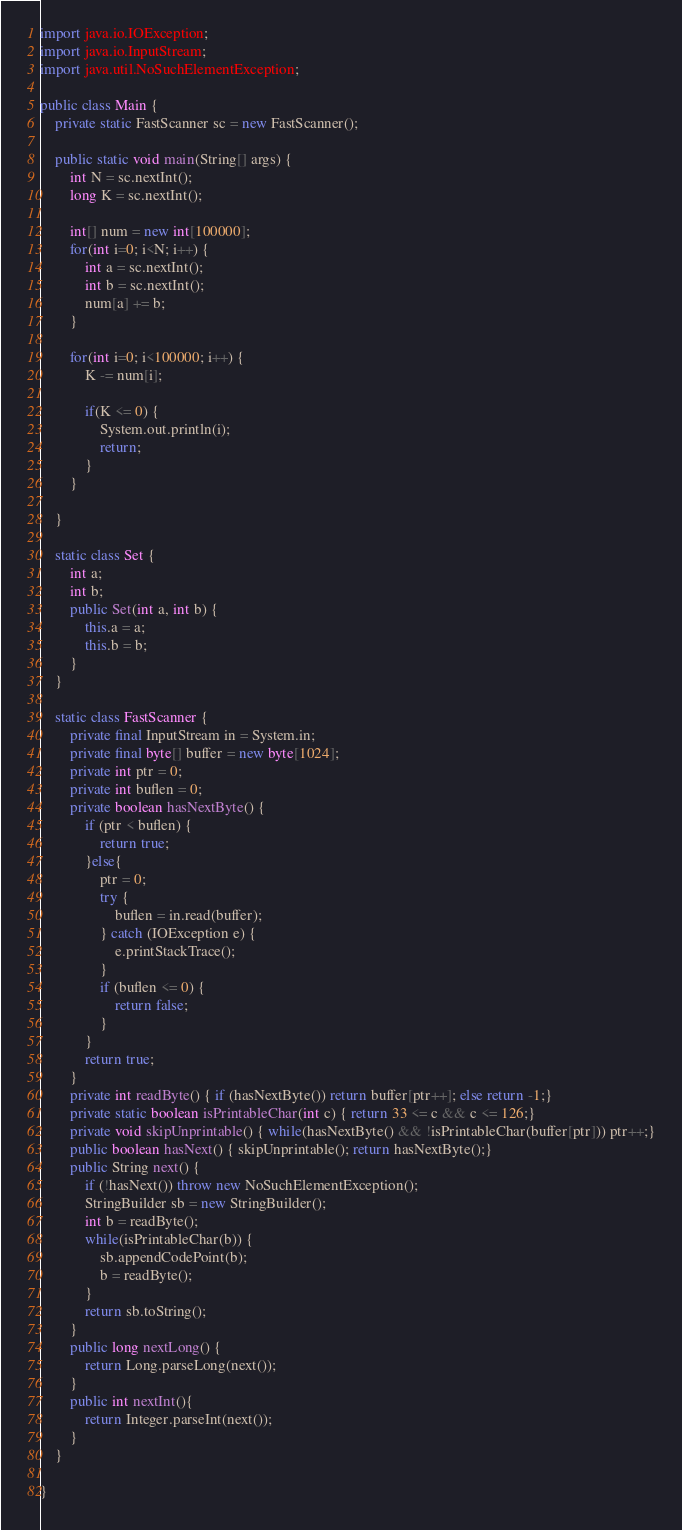Convert code to text. <code><loc_0><loc_0><loc_500><loc_500><_Java_>import java.io.IOException;
import java.io.InputStream;
import java.util.NoSuchElementException;

public class Main {
	private static FastScanner sc = new FastScanner();

	public static void main(String[] args) {
		int N = sc.nextInt();
		long K = sc.nextInt();
		
		int[] num = new int[100000];
		for(int i=0; i<N; i++) {
			int a = sc.nextInt();
			int b = sc.nextInt();
			num[a] += b;
		}
		
		for(int i=0; i<100000; i++) {
			K -= num[i];
			
			if(K <= 0) {
				System.out.println(i);
				return;
			}
		}

	}
	
	static class Set {
		int a;
		int b;
		public Set(int a, int b) {
			this.a = a;
			this.b = b;
		}
	}
	
	static class FastScanner {
	    private final InputStream in = System.in;
	    private final byte[] buffer = new byte[1024];
	    private int ptr = 0;
	    private int buflen = 0;
	    private boolean hasNextByte() {
	        if (ptr < buflen) {
	            return true;
	        }else{
	            ptr = 0;
	            try {
	                buflen = in.read(buffer);
	            } catch (IOException e) {
	                e.printStackTrace();
	            }
	            if (buflen <= 0) {
	                return false;
	            }
	        }
	        return true;
	    }
	    private int readByte() { if (hasNextByte()) return buffer[ptr++]; else return -1;}
	    private static boolean isPrintableChar(int c) { return 33 <= c && c <= 126;}
	    private void skipUnprintable() { while(hasNextByte() && !isPrintableChar(buffer[ptr])) ptr++;}
	    public boolean hasNext() { skipUnprintable(); return hasNextByte();}
	    public String next() {
	        if (!hasNext()) throw new NoSuchElementException();
	        StringBuilder sb = new StringBuilder();
	        int b = readByte();
	        while(isPrintableChar(b)) {
	            sb.appendCodePoint(b);
	            b = readByte();
	        }
	        return sb.toString();
	    }
	    public long nextLong() {
	        return Long.parseLong(next());
	    }
	    public int nextInt(){
	    	return Integer.parseInt(next());
	    }
	}

}</code> 